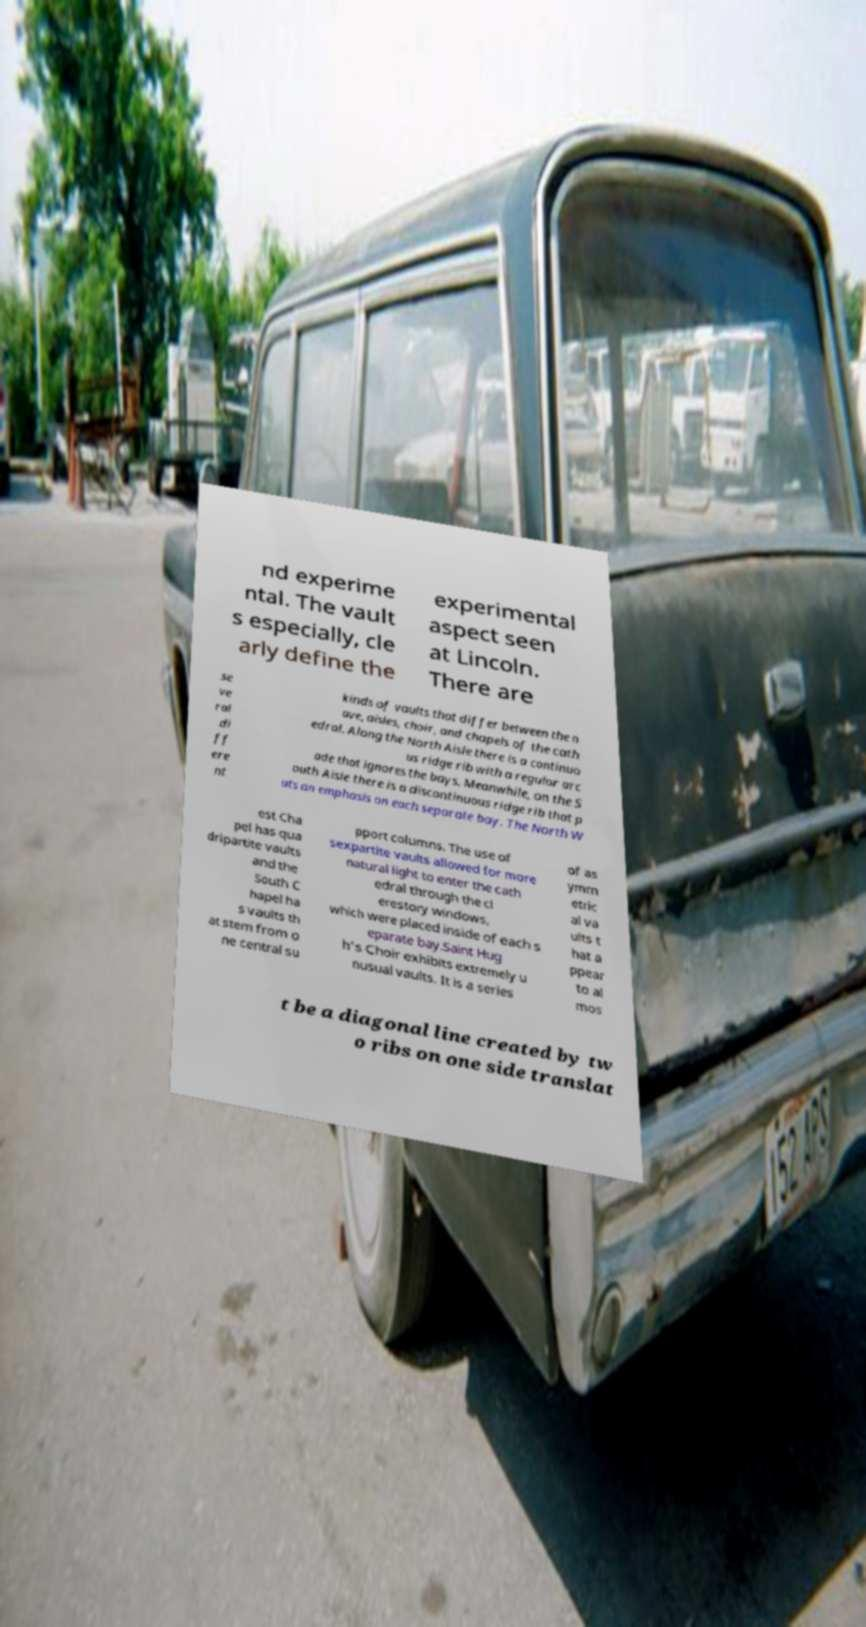I need the written content from this picture converted into text. Can you do that? nd experime ntal. The vault s especially, cle arly define the experimental aspect seen at Lincoln. There are se ve ral di ff ere nt kinds of vaults that differ between the n ave, aisles, choir, and chapels of the cath edral. Along the North Aisle there is a continuo us ridge rib with a regular arc ade that ignores the bays. Meanwhile, on the S outh Aisle there is a discontinuous ridge rib that p uts an emphasis on each separate bay. The North W est Cha pel has qua dripartite vaults and the South C hapel ha s vaults th at stem from o ne central su pport columns. The use of sexpartite vaults allowed for more natural light to enter the cath edral through the cl erestory windows, which were placed inside of each s eparate bay.Saint Hug h's Choir exhibits extremely u nusual vaults. It is a series of as ymm etric al va ults t hat a ppear to al mos t be a diagonal line created by tw o ribs on one side translat 